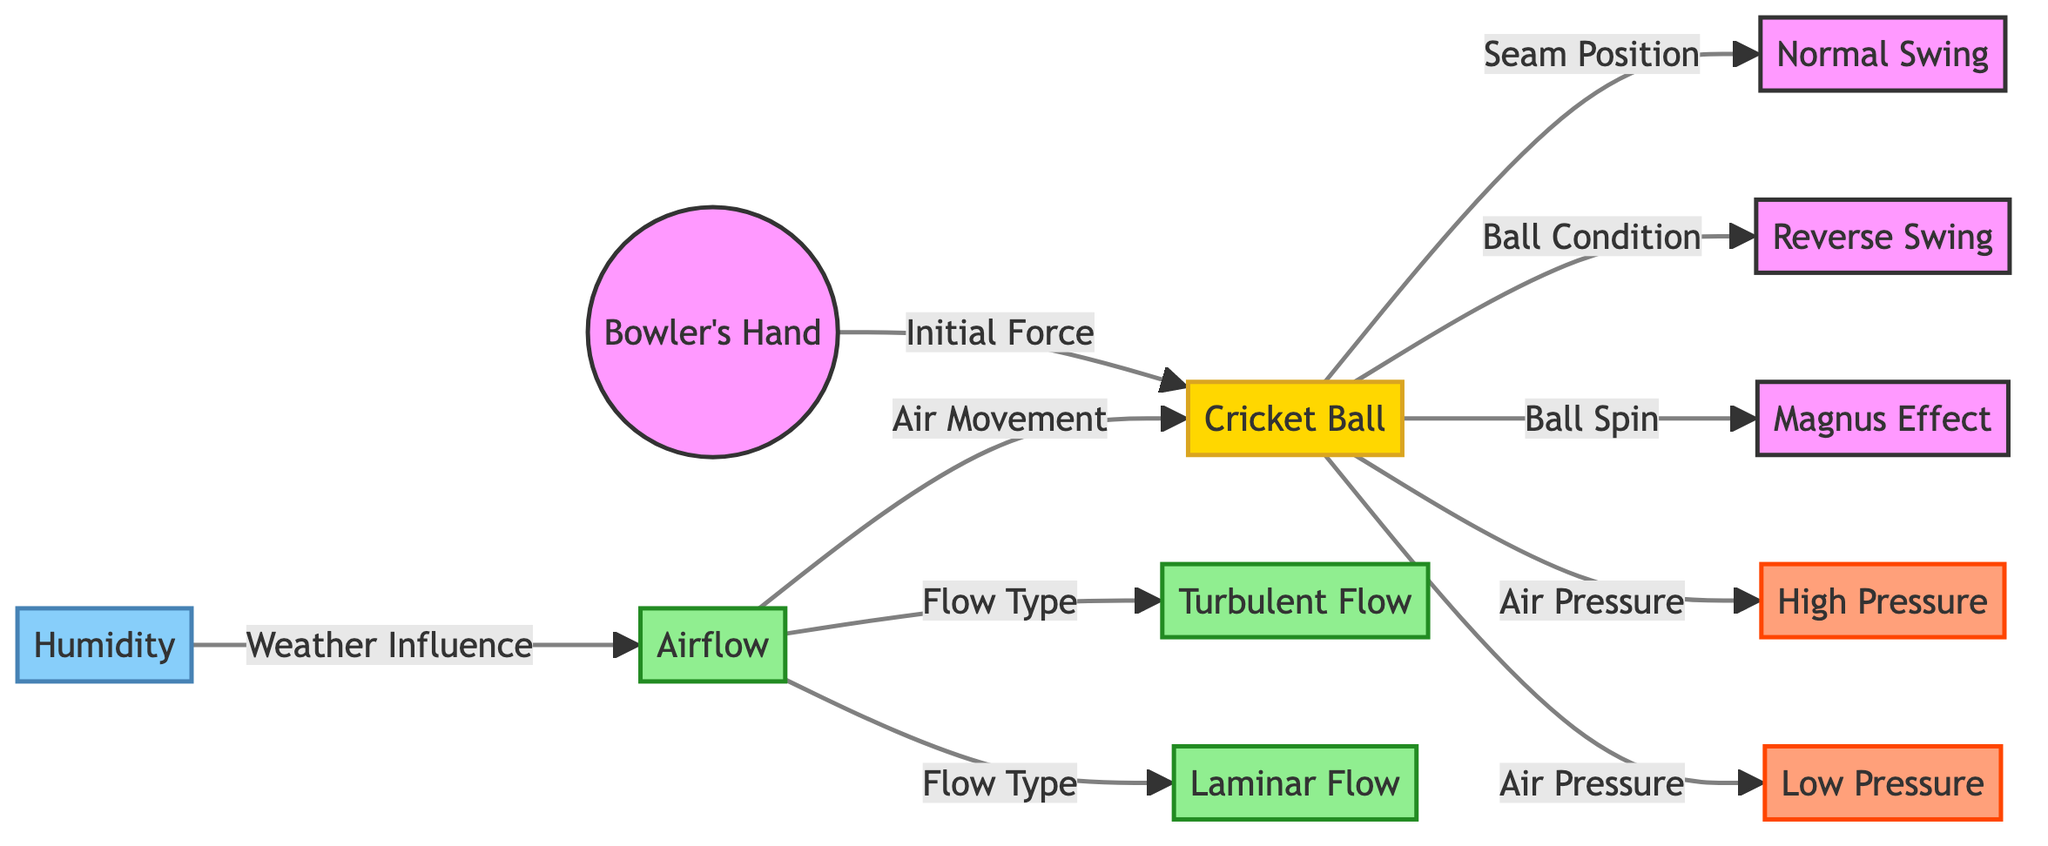What's the role of humidity in the diagram? The diagram shows that humidity influences the airflow. This indicates that local weather conditions, specifically humidity levels, can affect the behavior of the air around the cricket ball during bowling.
Answer: Weather Influence How many flow types are mentioned in the diagram? The diagram directly indicates two types of airflow: turbulent and laminar. Therefore, by counting these elements, we find that there are two flow types presented.
Answer: Two What determines the normal swing of the cricket ball? The diagram connects the cricket ball with the seam position specifically for normal swing, suggesting that seam orientation is the key determinant.
Answer: Seam Position Which effect is attributed to the spin of the ball? The spin of the ball in the diagram is linked directly to the Magnus Effect, indicating that this phenomenon is a result of the ball's rotation.
Answer: Magnus Effect What is indicated as a result of air pressure acting on the cricket ball? The diagram shows both high pressure and low pressure noted as outcomes from the air pressure acting on the cricket ball. Hence, both pressures are acknowledged.
Answer: High Pressure and Low Pressure How does airflow relate to local weather conditions in the diagram? The diagram illustrates that airflow is affected by humidity, thereby demonstrating a direct connection between local weather conditions and the airflow around the cricket ball.
Answer: Air Movement What initial force influences the cricket ball in the diagram? The diagram depicts the bowling hand applying an initial force to the cricket ball, indicating that this force is fundamental to initiating the bowling process.
Answer: Initial Force 